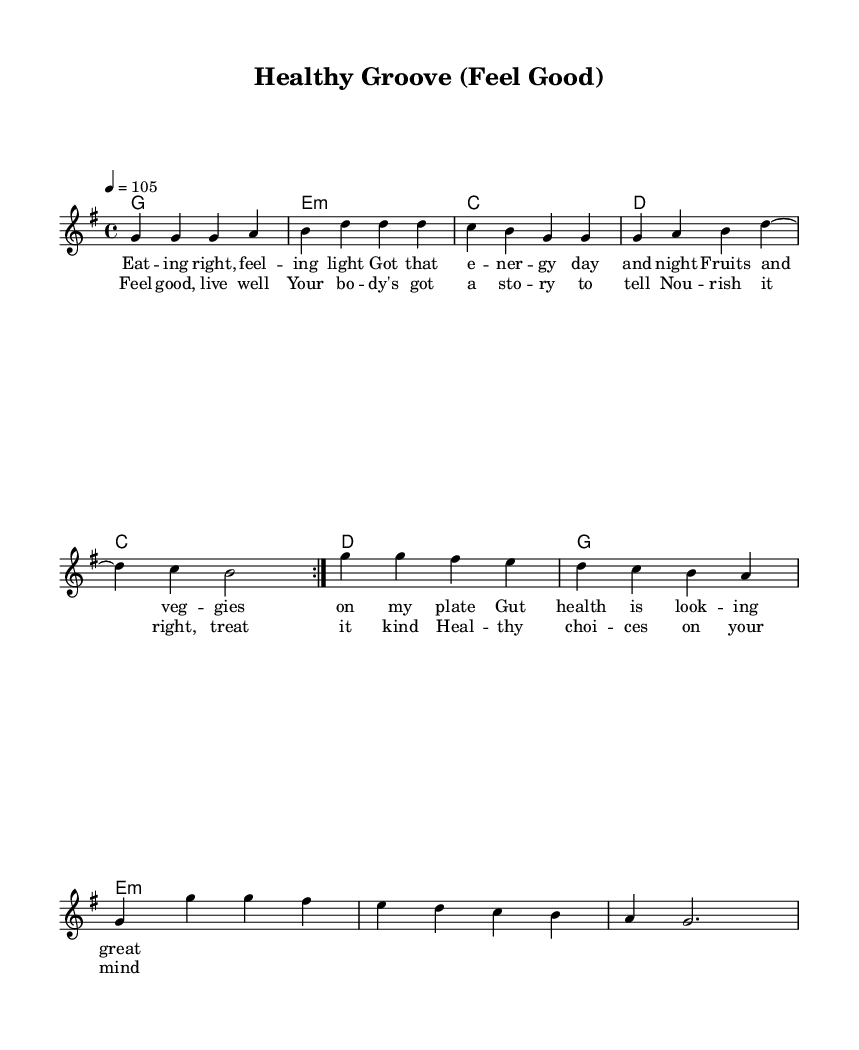What is the key signature of this music? The key signature is G major, which has one sharp (F#). It is indicated at the beginning of the staff.
Answer: G major What is the time signature of the piece? The time signature is 4/4, which means there are four beats in each measure and the quarter note gets one beat. This is commonly found at the beginning of the score.
Answer: 4/4 What is the tempo marking in this score? The tempo marking is 4 = 105, indicating that there are 105 beats per minute, and each beat is the quarter note. This is stated at the beginning of the piece.
Answer: 105 How many measures are there in the verse? The verse consists of four measures, which can be counted from the first set of lyrics under the melody. Each group of notes corresponds to one measure.
Answer: 4 What is the primary theme of the lyrics in the chorus? The primary theme of the chorus revolves around feeling good and making healthy lifestyle choices, emphasized through phrases about nourishment and caring for one's body. This can be determined by reading the lyrics.
Answer: Healthy lifestyle Which chord appears first in the harmonies? The first chord in the harmonies is G major, as indicated at the beginning of the chord progression. All chords are listed in order from the start of the score.
Answer: G What is the lyrical focus of the song? The lyrical focus of the song is on promoting healthy eating and lifestyle choices, which is evident from both the verse and chorus lyrics emphasizing gut health, energy, and nourishment.
Answer: Healthy eating 